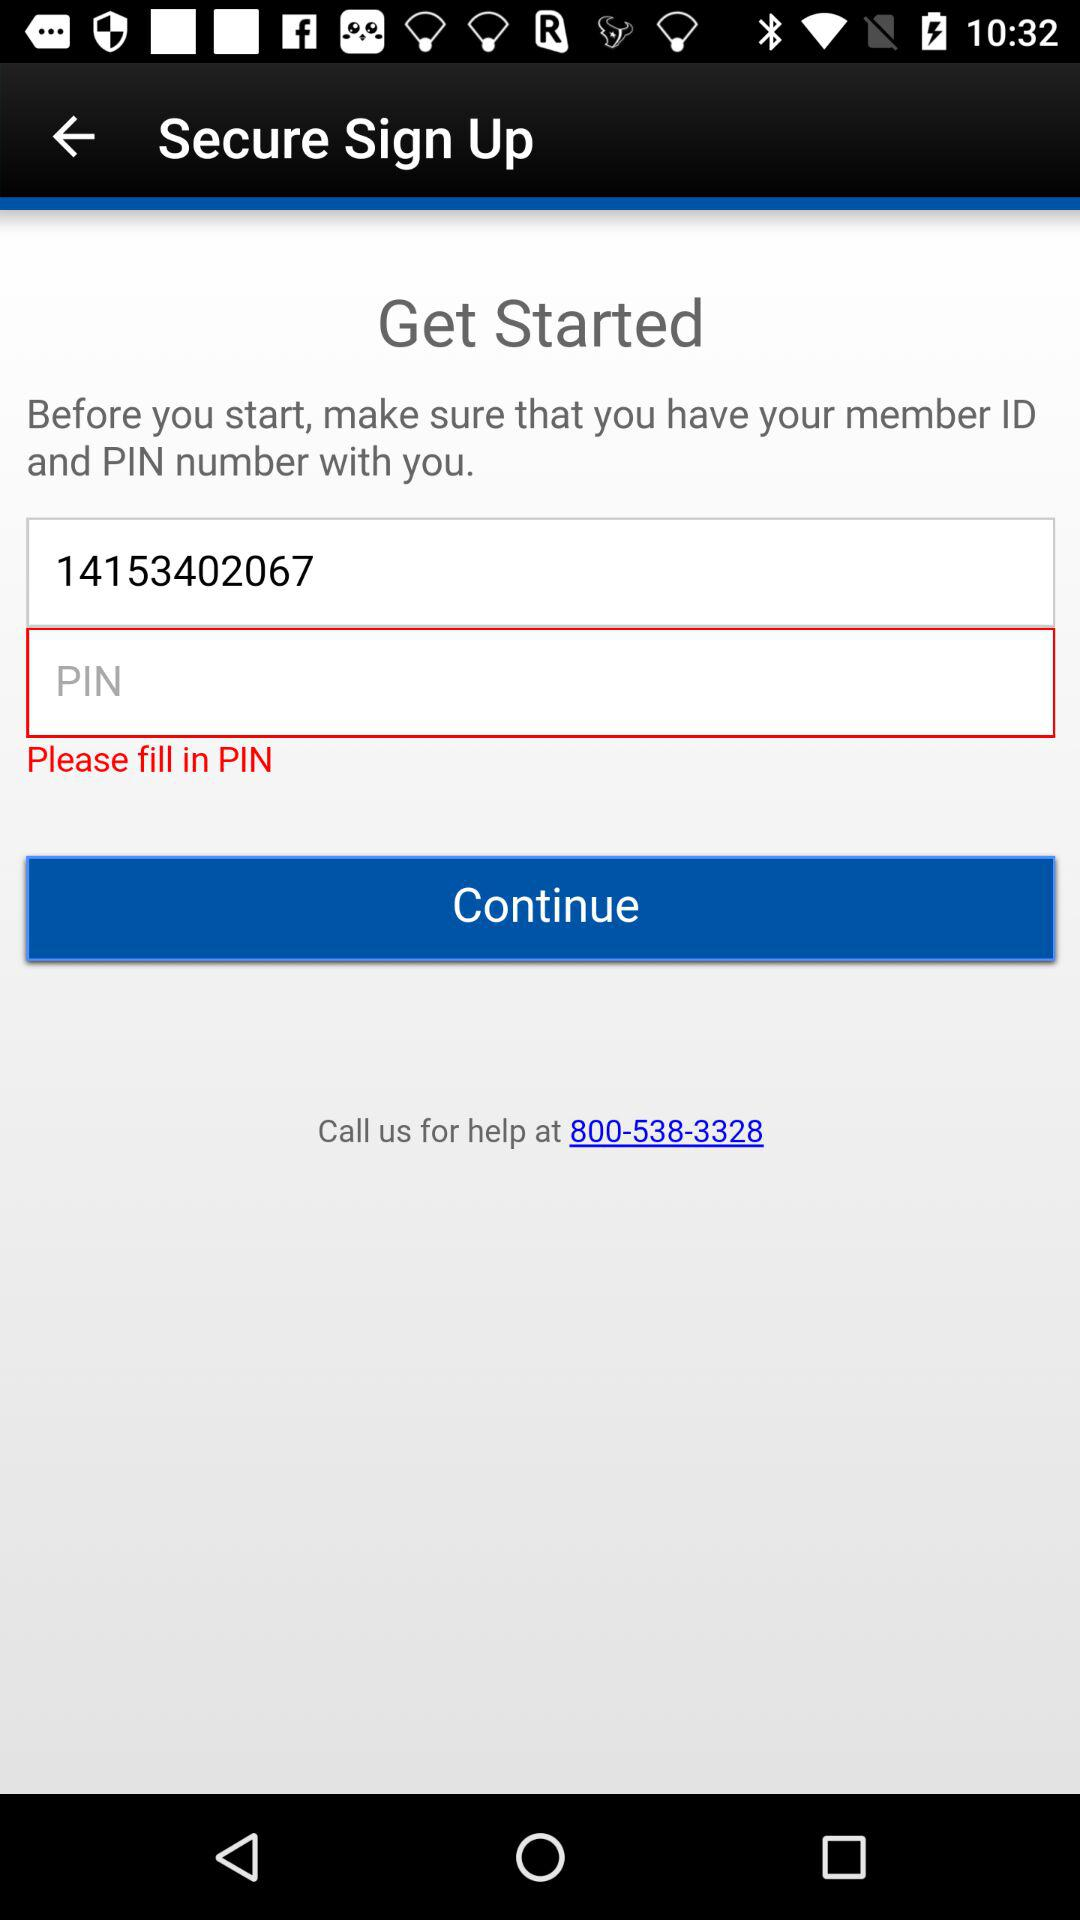What's the member ID? The member ID is 14153402067. 